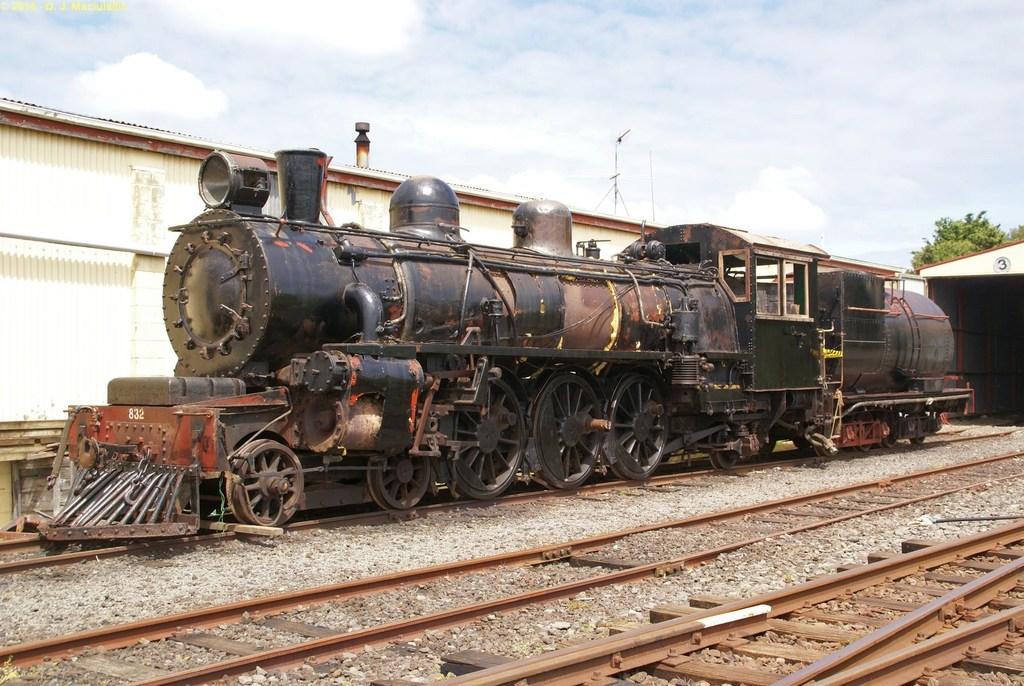Can you describe this image briefly? In this image there is a steam engine on the tracks, in front of the image there are tracks on the surface, behind the steam engine there is a tree and a shed, beside the steam engine there is a metal shed. 